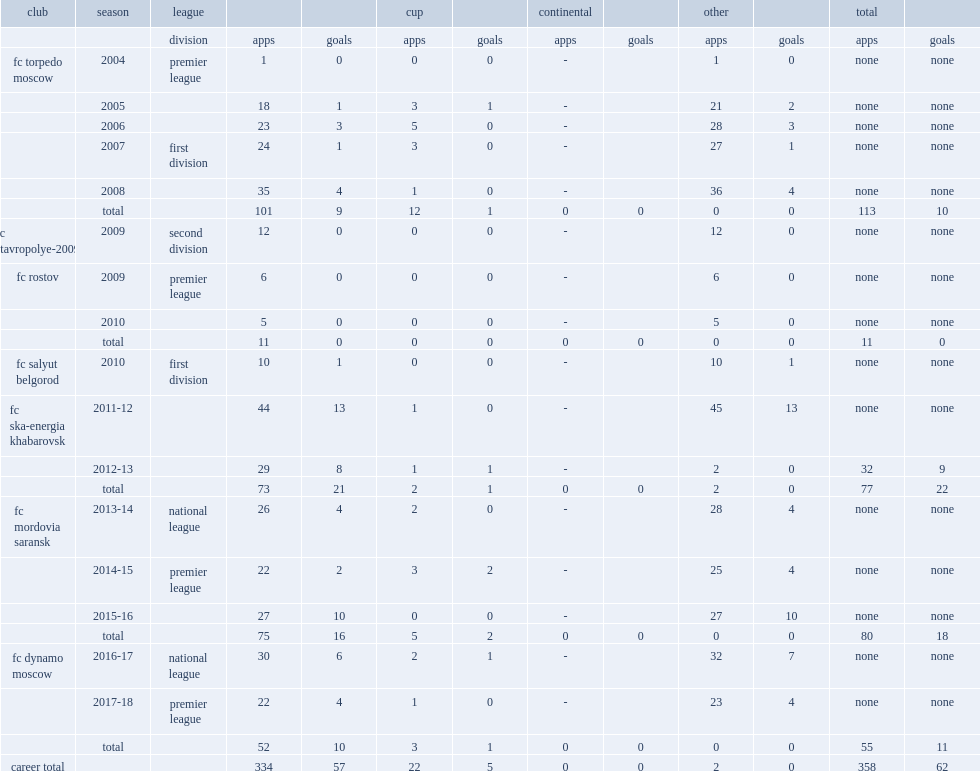Which club did yevgeni lutsenko play for in 2004? Fc torpedo moscow. 